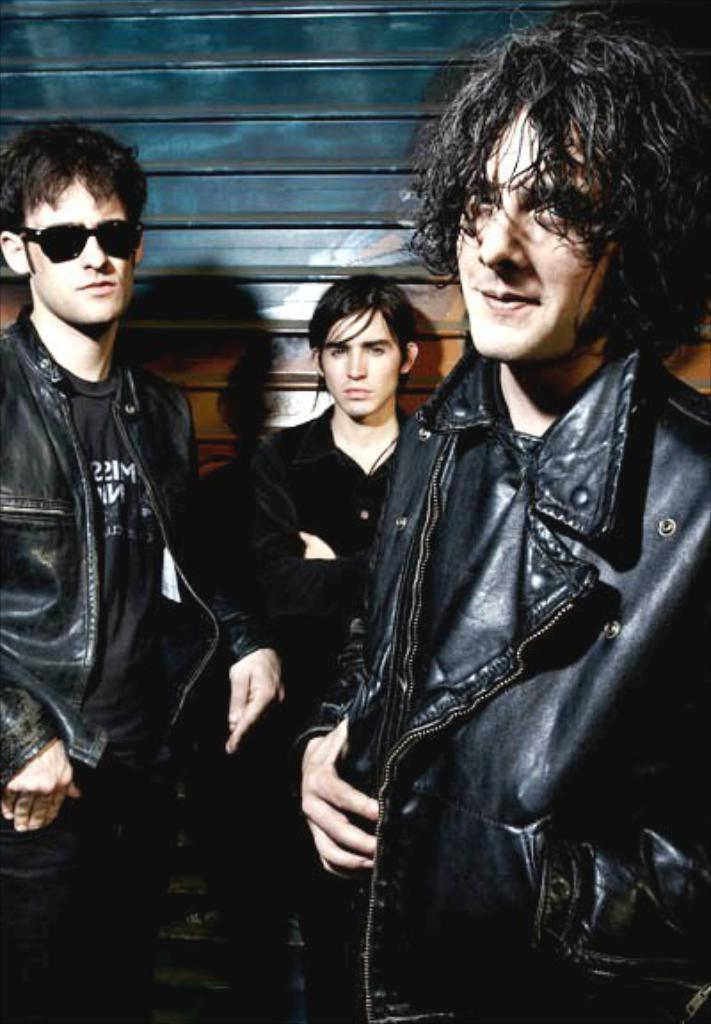How many people are in the image? There are three men in the image. What are the men doing in the image? The men are standing. What color clothes are the men wearing? The men are wearing dark color clothes. What can be seen in the background of the image? There is a wall in the background of the image. What type of hat is the clam wearing in the image? There is no clam or hat present in the image. How much fuel is needed to power the men's movements in the image? The men are standing still in the image, so no fuel is needed for their movements. 